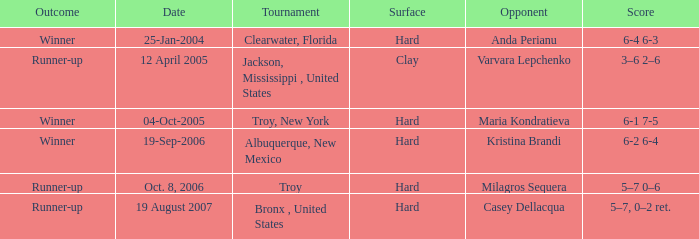What is the score of the game that was played against Maria Kondratieva? 6-1 7-5. 